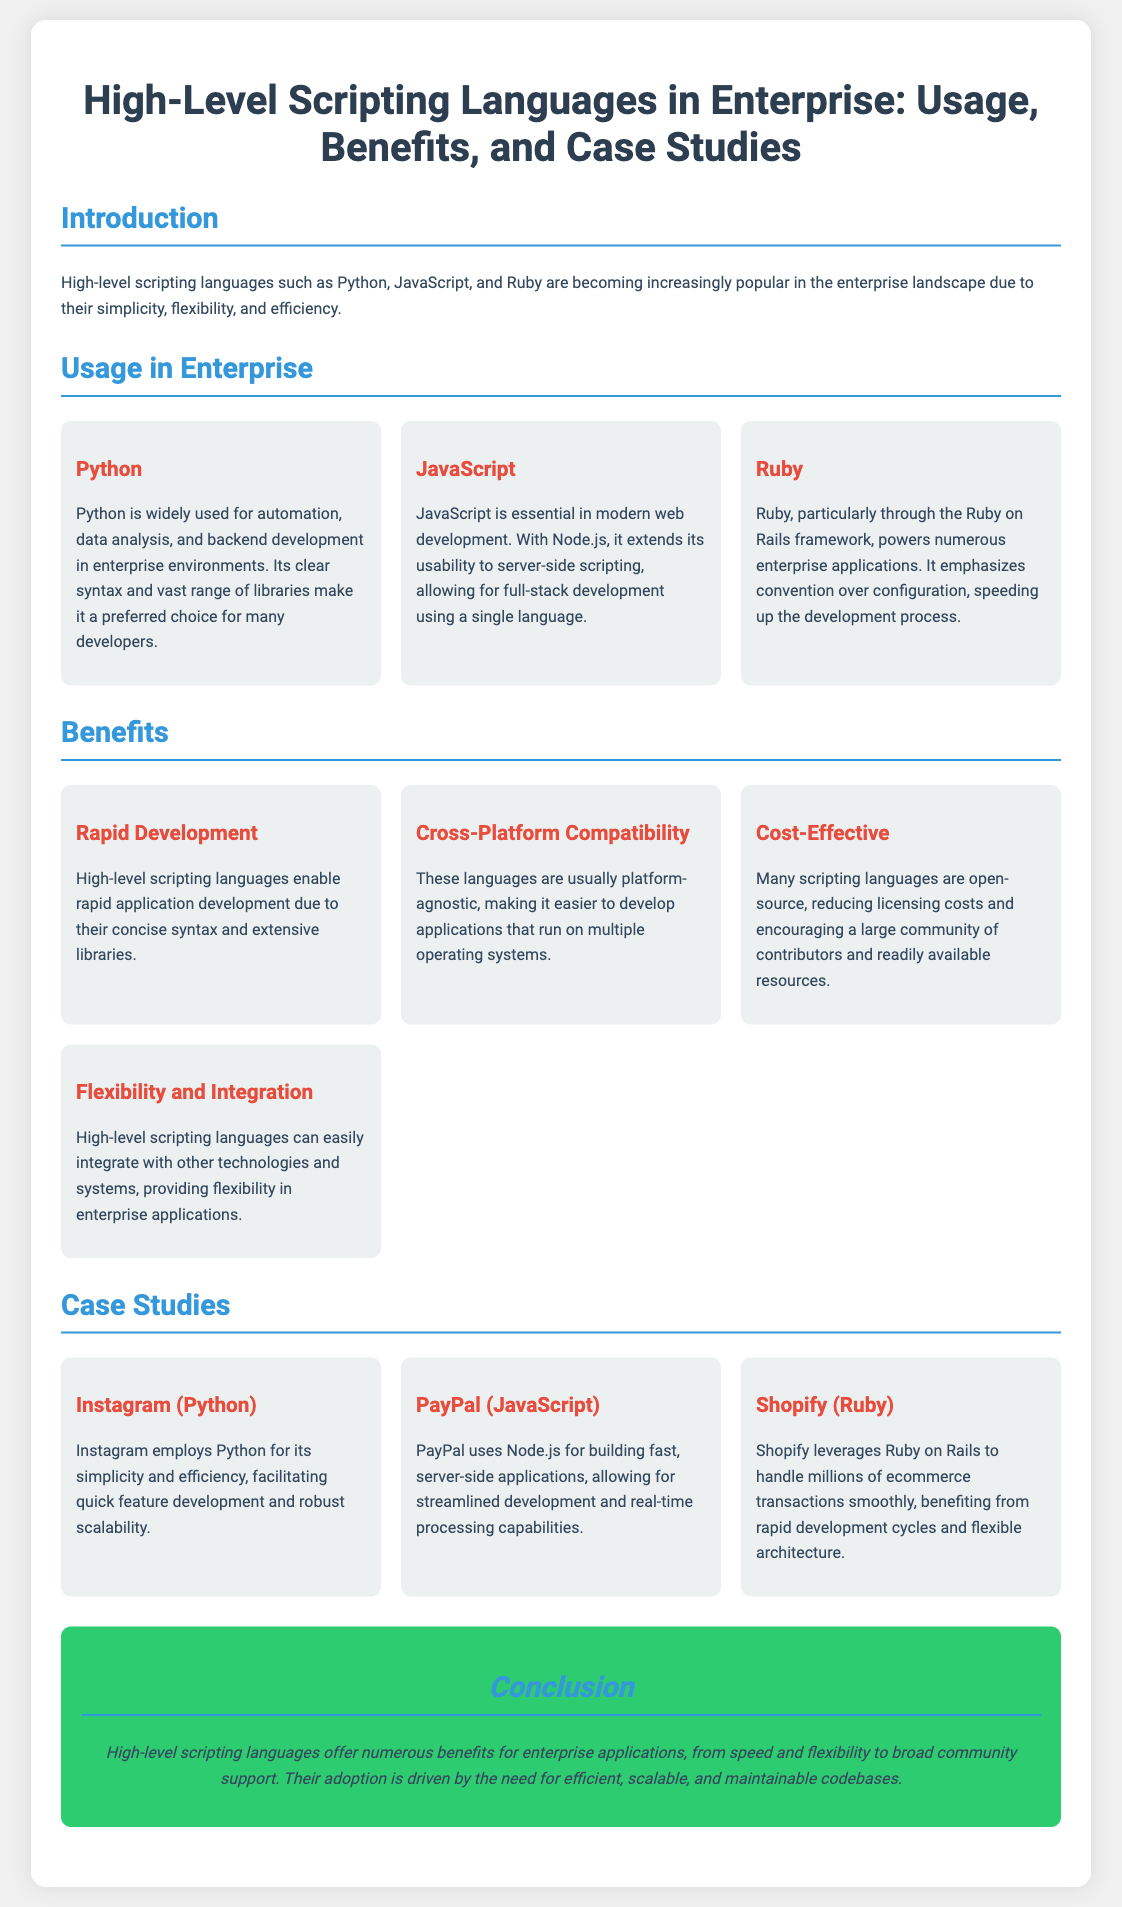What high-level scripting languages are mentioned? The document lists Python, JavaScript, and Ruby as high-level scripting languages used in enterprises.
Answer: Python, JavaScript, Ruby What is the primary benefit of high-level scripting languages for development? The document states that one of the key benefits is rapid application development due to their concise syntax and extensive libraries.
Answer: Rapid Development Which company uses Python for quick feature development? Instagram is highlighted as a company that employs Python to facilitate quick feature development.
Answer: Instagram Name one benefit related to cost mentioned in the document. The document mentions that many scripting languages are open-source, reducing licensing costs.
Answer: Cost-Effective Which framework is associated with Ruby in enterprise applications? The document mentions Ruby on Rails as the framework that powers numerous enterprise applications using Ruby.
Answer: Ruby on Rails What does PayPal use for building fast server-side applications? PayPal is noted to use Node.js for building fast, server-side applications.
Answer: Node.js How does high-level scripting languages affect cross-platform compatibility? The document states that these languages are usually platform-agnostic, facilitating development across multiple operating systems.
Answer: Cross-Platform Compatibility What is emphasized by Ruby in its development approach? The document highlights that Ruby emphasizes convention over configuration, which speeds up the development process.
Answer: Convention over Configuration What type of document is this content presented in? This document is presented as a poster, detailing usage, benefits, and case studies of high-level scripting languages in enterprise.
Answer: Poster 